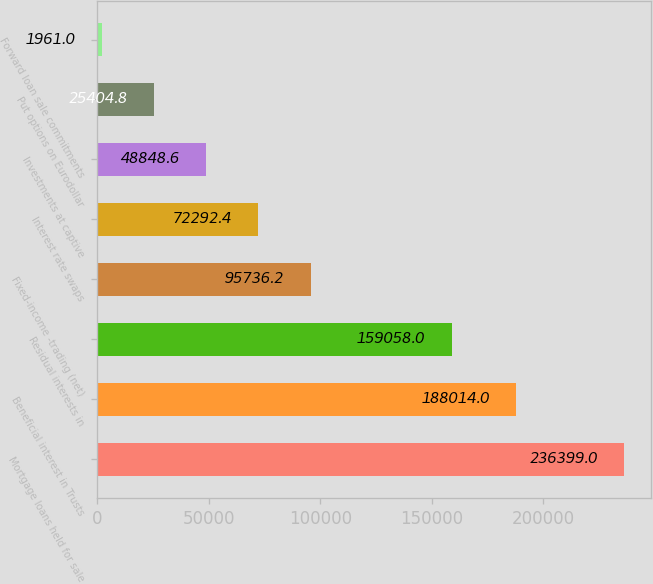Convert chart. <chart><loc_0><loc_0><loc_500><loc_500><bar_chart><fcel>Mortgage loans held for sale<fcel>Beneficial interest in Trusts<fcel>Residual interests in<fcel>Fixed-income -trading (net)<fcel>Interest rate swaps<fcel>Investments at captive<fcel>Put options on Eurodollar<fcel>Forward loan sale commitments<nl><fcel>236399<fcel>188014<fcel>159058<fcel>95736.2<fcel>72292.4<fcel>48848.6<fcel>25404.8<fcel>1961<nl></chart> 